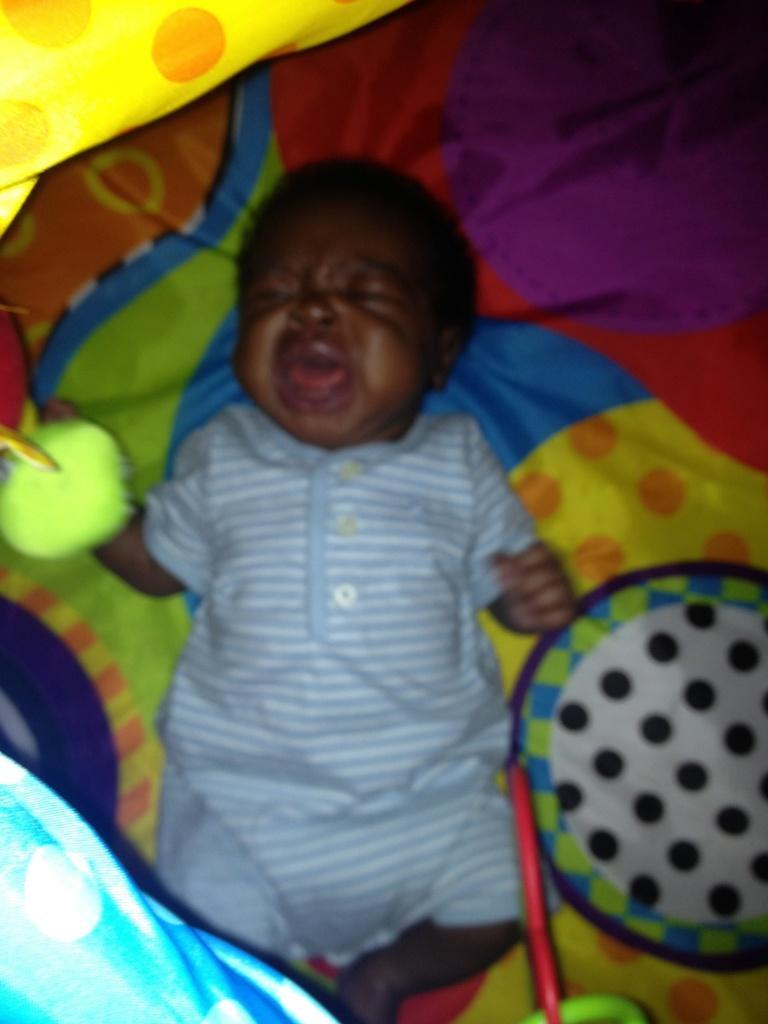Can you describe this image briefly? In this image we can see a baby crying and lying on the bed. 